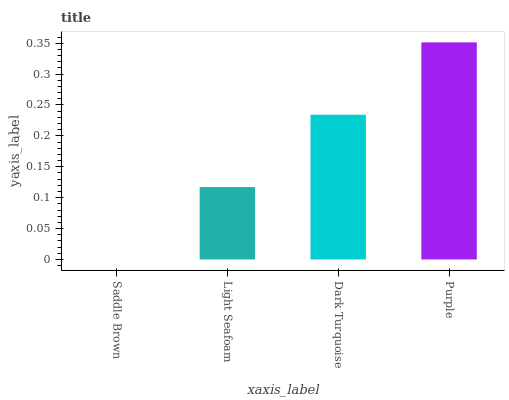Is Saddle Brown the minimum?
Answer yes or no. Yes. Is Purple the maximum?
Answer yes or no. Yes. Is Light Seafoam the minimum?
Answer yes or no. No. Is Light Seafoam the maximum?
Answer yes or no. No. Is Light Seafoam greater than Saddle Brown?
Answer yes or no. Yes. Is Saddle Brown less than Light Seafoam?
Answer yes or no. Yes. Is Saddle Brown greater than Light Seafoam?
Answer yes or no. No. Is Light Seafoam less than Saddle Brown?
Answer yes or no. No. Is Dark Turquoise the high median?
Answer yes or no. Yes. Is Light Seafoam the low median?
Answer yes or no. Yes. Is Purple the high median?
Answer yes or no. No. Is Dark Turquoise the low median?
Answer yes or no. No. 